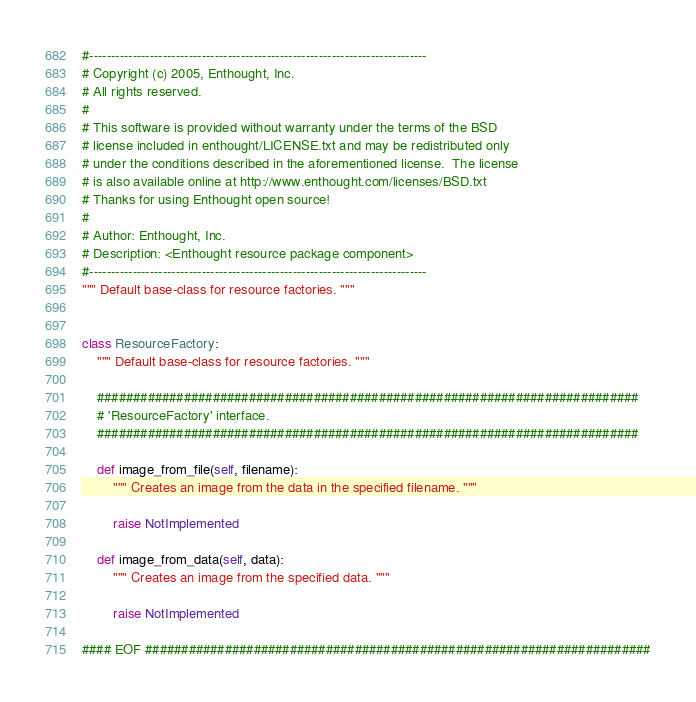Convert code to text. <code><loc_0><loc_0><loc_500><loc_500><_Python_>#------------------------------------------------------------------------------
# Copyright (c) 2005, Enthought, Inc.
# All rights reserved.
#
# This software is provided without warranty under the terms of the BSD
# license included in enthought/LICENSE.txt and may be redistributed only
# under the conditions described in the aforementioned license.  The license
# is also available online at http://www.enthought.com/licenses/BSD.txt
# Thanks for using Enthought open source!
#
# Author: Enthought, Inc.
# Description: <Enthought resource package component>
#------------------------------------------------------------------------------
""" Default base-class for resource factories. """


class ResourceFactory:
    """ Default base-class for resource factories. """

    ###########################################################################
    # 'ResourceFactory' interface.
    ###########################################################################

    def image_from_file(self, filename):
        """ Creates an image from the data in the specified filename. """

        raise NotImplemented

    def image_from_data(self, data):
        """ Creates an image from the specified data. """

        raise NotImplemented

#### EOF ######################################################################
</code> 